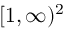Convert formula to latex. <formula><loc_0><loc_0><loc_500><loc_500>[ 1 , \infty ) ^ { 2 }</formula> 